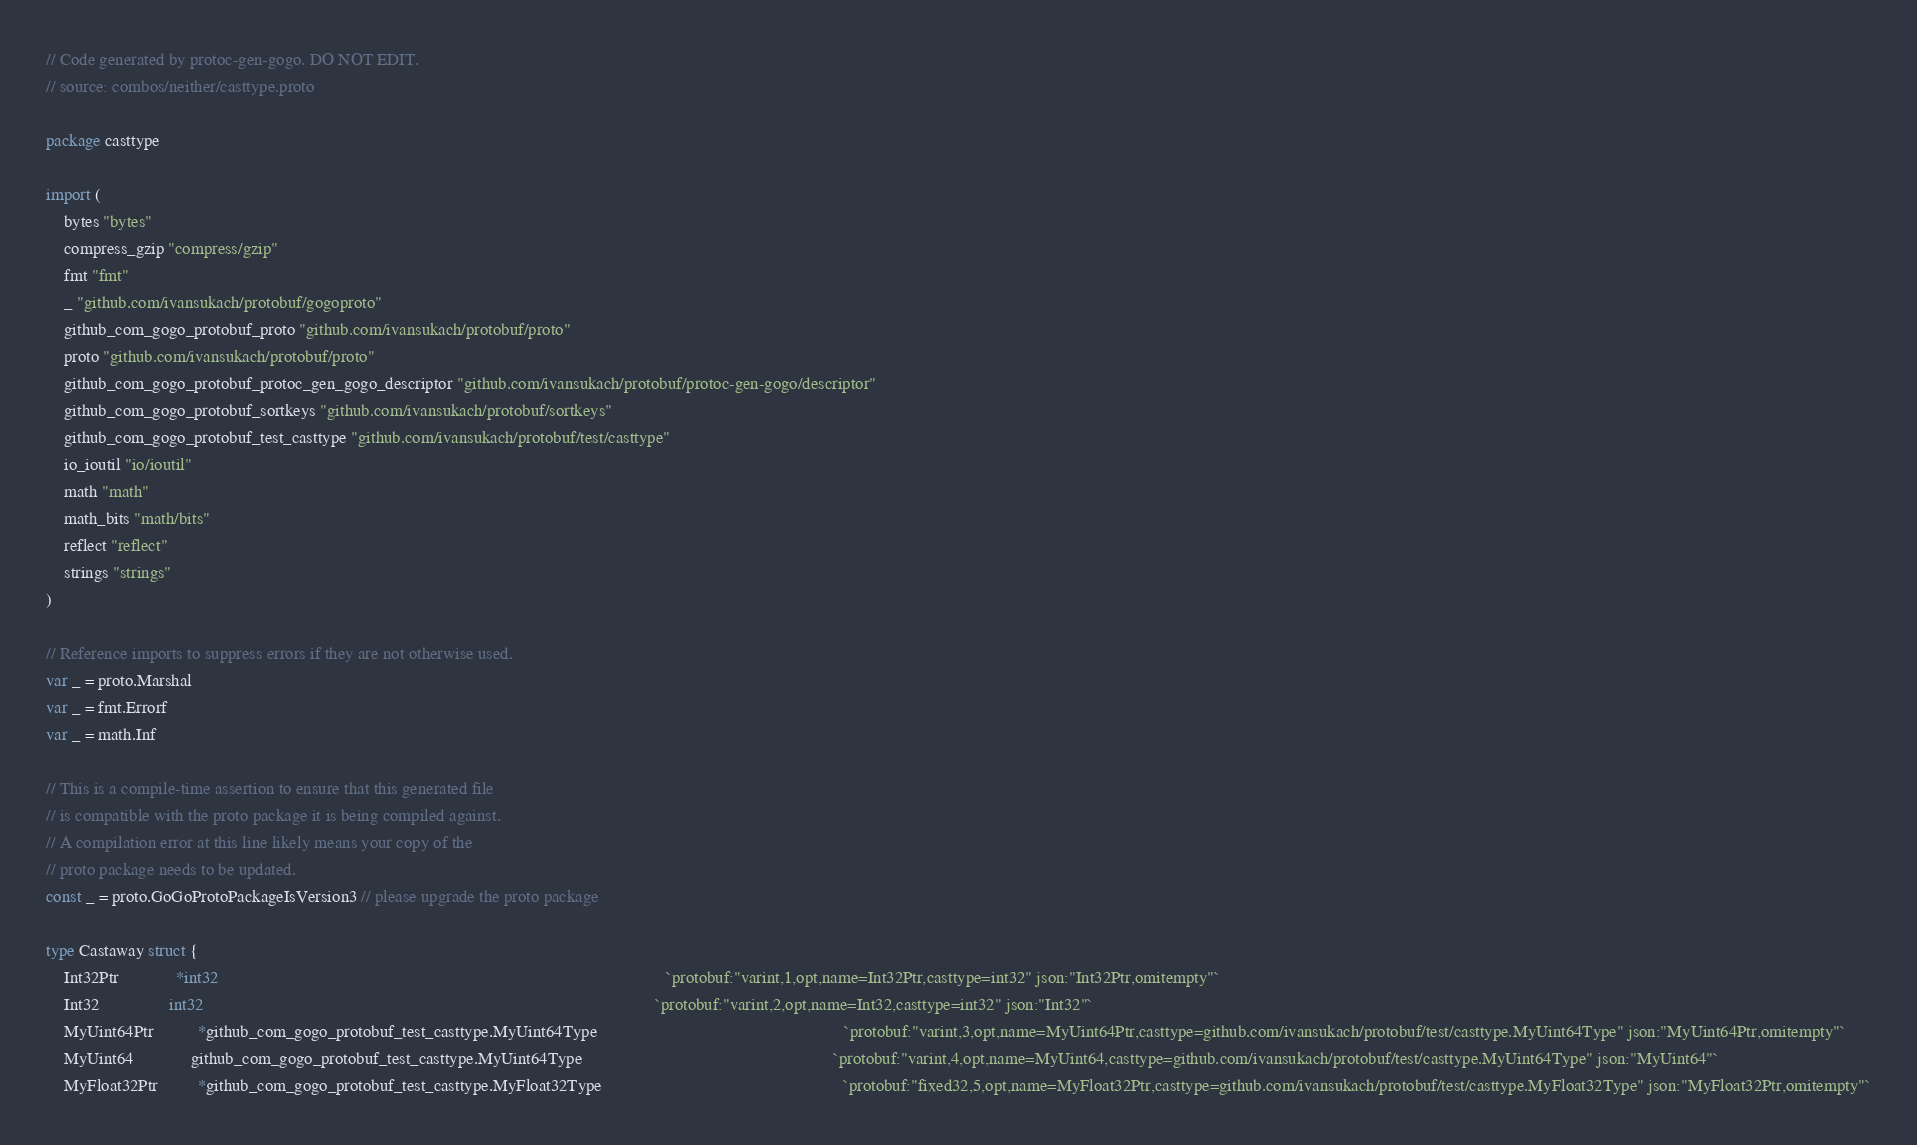<code> <loc_0><loc_0><loc_500><loc_500><_Go_>// Code generated by protoc-gen-gogo. DO NOT EDIT.
// source: combos/neither/casttype.proto

package casttype

import (
	bytes "bytes"
	compress_gzip "compress/gzip"
	fmt "fmt"
	_ "github.com/ivansukach/protobuf/gogoproto"
	github_com_gogo_protobuf_proto "github.com/ivansukach/protobuf/proto"
	proto "github.com/ivansukach/protobuf/proto"
	github_com_gogo_protobuf_protoc_gen_gogo_descriptor "github.com/ivansukach/protobuf/protoc-gen-gogo/descriptor"
	github_com_gogo_protobuf_sortkeys "github.com/ivansukach/protobuf/sortkeys"
	github_com_gogo_protobuf_test_casttype "github.com/ivansukach/protobuf/test/casttype"
	io_ioutil "io/ioutil"
	math "math"
	math_bits "math/bits"
	reflect "reflect"
	strings "strings"
)

// Reference imports to suppress errors if they are not otherwise used.
var _ = proto.Marshal
var _ = fmt.Errorf
var _ = math.Inf

// This is a compile-time assertion to ensure that this generated file
// is compatible with the proto package it is being compiled against.
// A compilation error at this line likely means your copy of the
// proto package needs to be updated.
const _ = proto.GoGoProtoPackageIsVersion3 // please upgrade the proto package

type Castaway struct {
	Int32Ptr             *int32                                                                                                      `protobuf:"varint,1,opt,name=Int32Ptr,casttype=int32" json:"Int32Ptr,omitempty"`
	Int32                int32                                                                                                       `protobuf:"varint,2,opt,name=Int32,casttype=int32" json:"Int32"`
	MyUint64Ptr          *github_com_gogo_protobuf_test_casttype.MyUint64Type                                                        `protobuf:"varint,3,opt,name=MyUint64Ptr,casttype=github.com/ivansukach/protobuf/test/casttype.MyUint64Type" json:"MyUint64Ptr,omitempty"`
	MyUint64             github_com_gogo_protobuf_test_casttype.MyUint64Type                                                         `protobuf:"varint,4,opt,name=MyUint64,casttype=github.com/ivansukach/protobuf/test/casttype.MyUint64Type" json:"MyUint64"`
	MyFloat32Ptr         *github_com_gogo_protobuf_test_casttype.MyFloat32Type                                                       `protobuf:"fixed32,5,opt,name=MyFloat32Ptr,casttype=github.com/ivansukach/protobuf/test/casttype.MyFloat32Type" json:"MyFloat32Ptr,omitempty"`</code> 